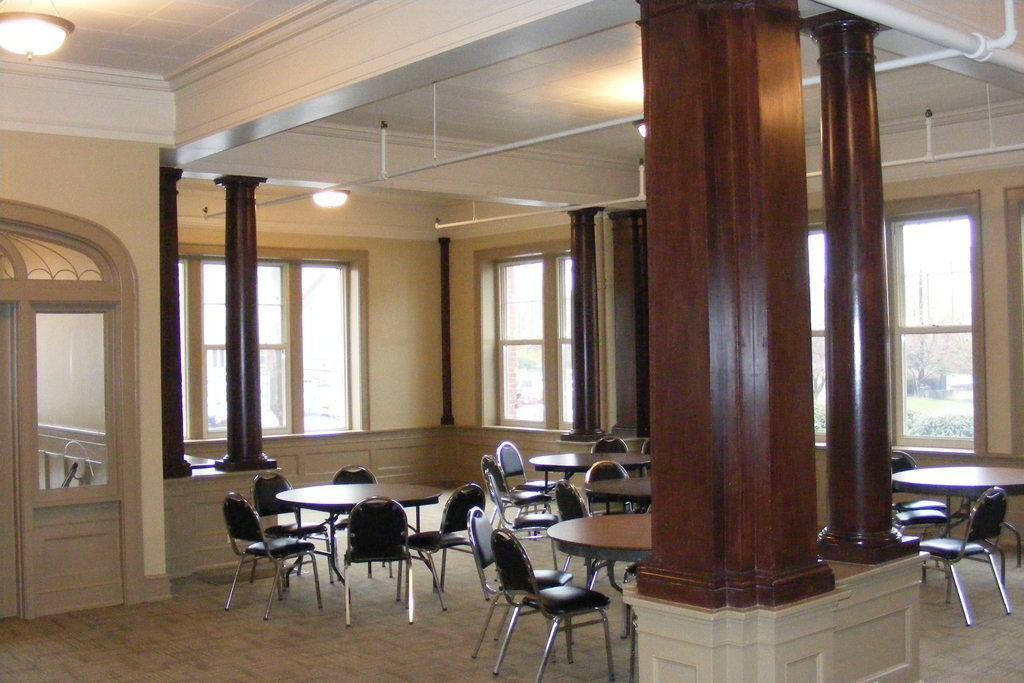Describe this image in one or two sentences. In this image we can see the inside view of the house that includes windows, pillars, stands, chairs, tables, door and lights. 